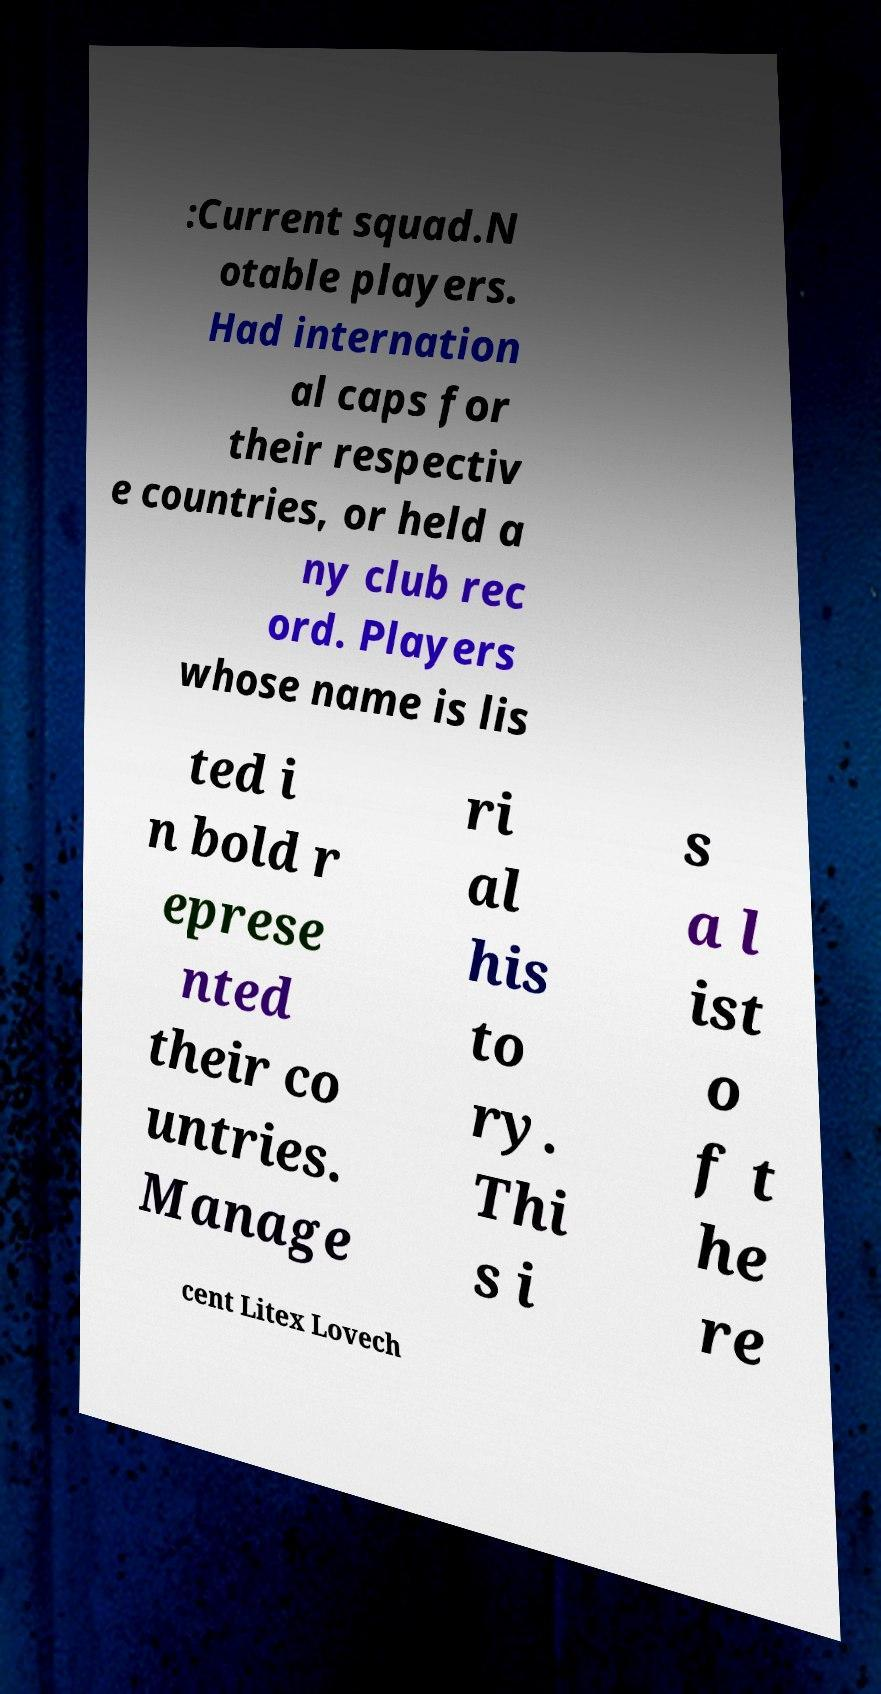Please read and relay the text visible in this image. What does it say? :Current squad.N otable players. Had internation al caps for their respectiv e countries, or held a ny club rec ord. Players whose name is lis ted i n bold r eprese nted their co untries. Manage ri al his to ry. Thi s i s a l ist o f t he re cent Litex Lovech 